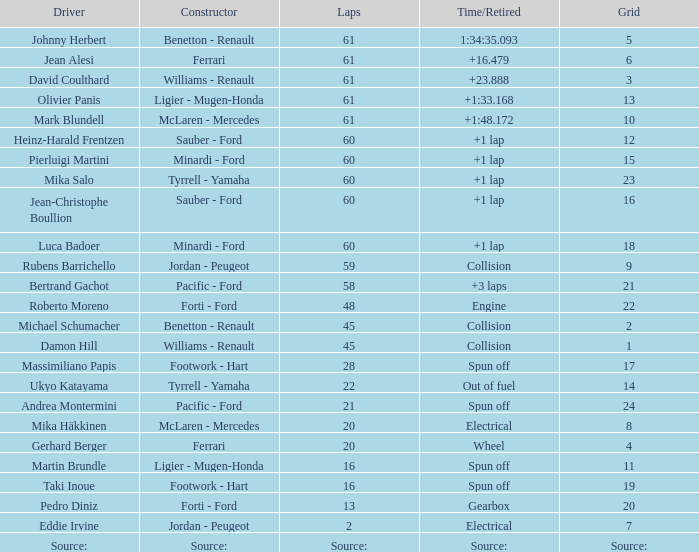How many laps does jean-christophe boullion have with a time/retired of +1 lap? 60.0. 